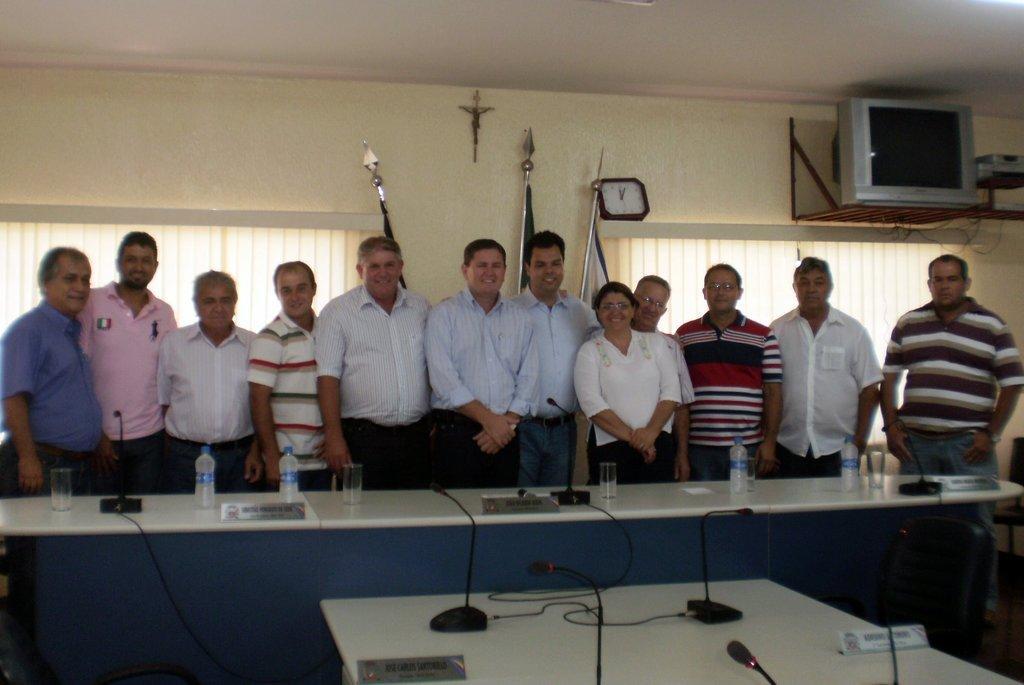How would you summarize this image in a sentence or two? This is a room and there are few people standing here. In front of them there is a table and we see glass and water bottles on the table. There is a microphone here. In the background we can see wall,curtain and a TV. 